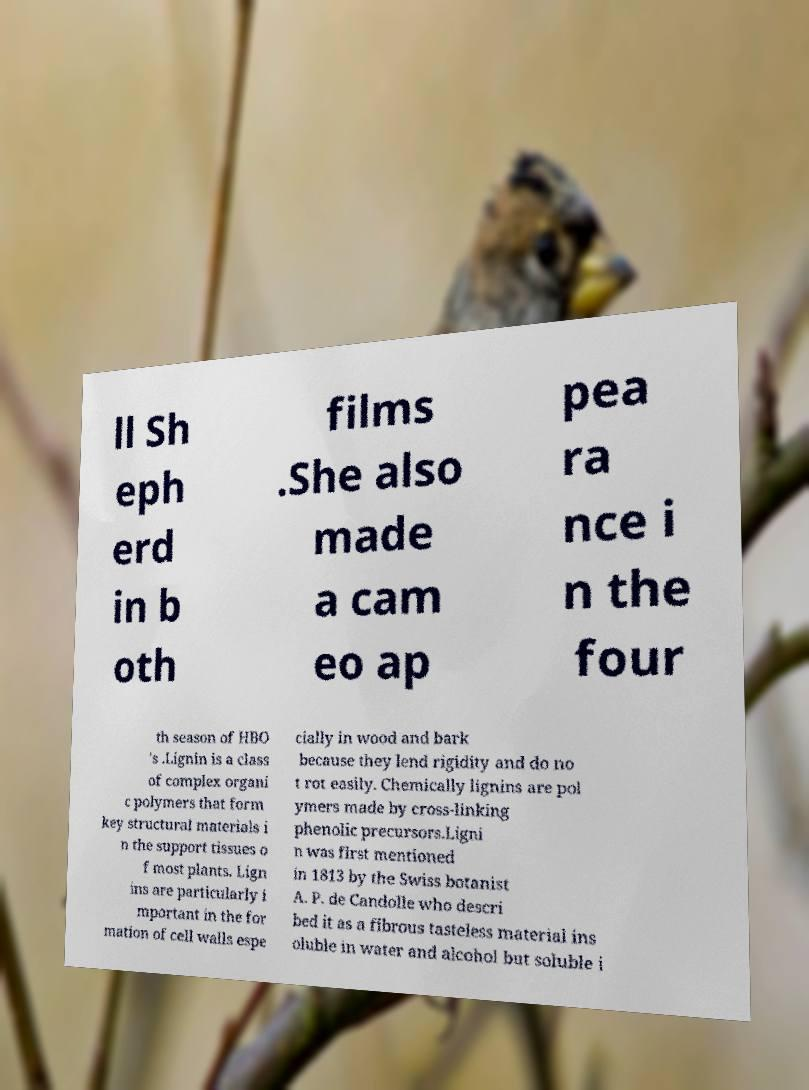For documentation purposes, I need the text within this image transcribed. Could you provide that? ll Sh eph erd in b oth films .She also made a cam eo ap pea ra nce i n the four th season of HBO 's .Lignin is a class of complex organi c polymers that form key structural materials i n the support tissues o f most plants. Lign ins are particularly i mportant in the for mation of cell walls espe cially in wood and bark because they lend rigidity and do no t rot easily. Chemically lignins are pol ymers made by cross-linking phenolic precursors.Ligni n was first mentioned in 1813 by the Swiss botanist A. P. de Candolle who descri bed it as a fibrous tasteless material ins oluble in water and alcohol but soluble i 